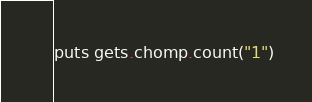Convert code to text. <code><loc_0><loc_0><loc_500><loc_500><_Ruby_>puts gets.chomp.count("1")</code> 